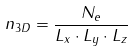Convert formula to latex. <formula><loc_0><loc_0><loc_500><loc_500>n _ { 3 D } = \frac { N _ { e } } { L _ { x } \cdot L _ { y } \cdot L _ { z } }</formula> 